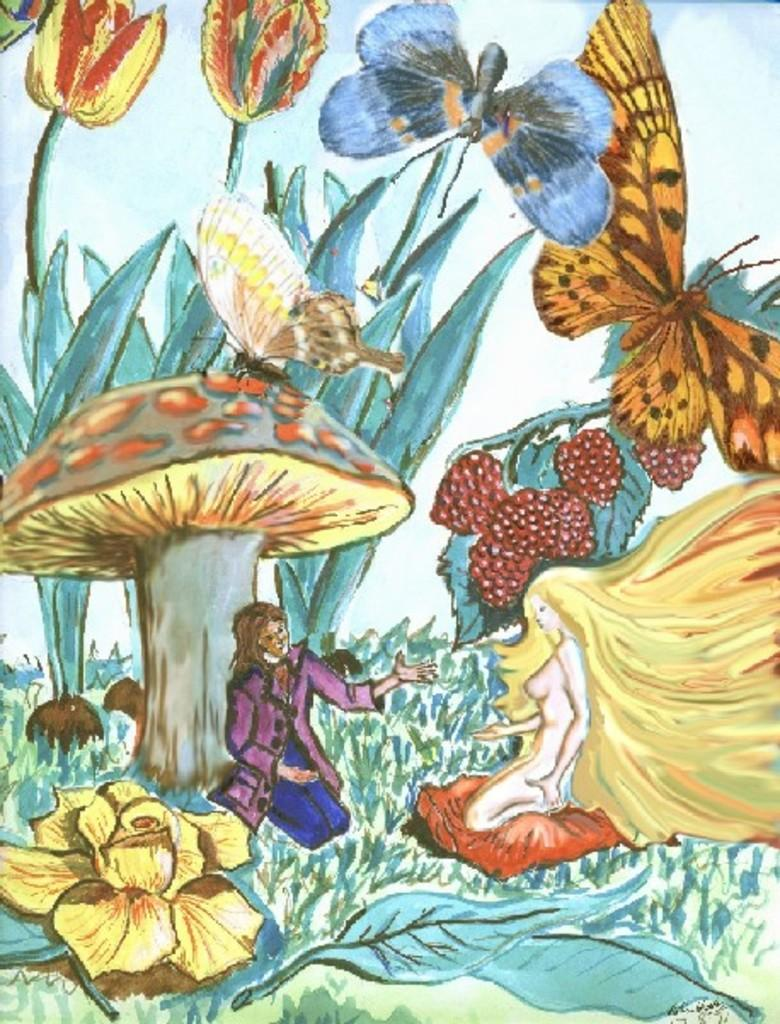How many persons are depicted in the painting? The painting contains two persons. What type of natural elements can be seen in the painting? There are leaves, flowers, and plants in the painting. Are there any animals present in the painting? Yes, there are butterflies in the painting. Are there any icicles hanging from the plants in the painting? No, there are no icicles present in the painting. 